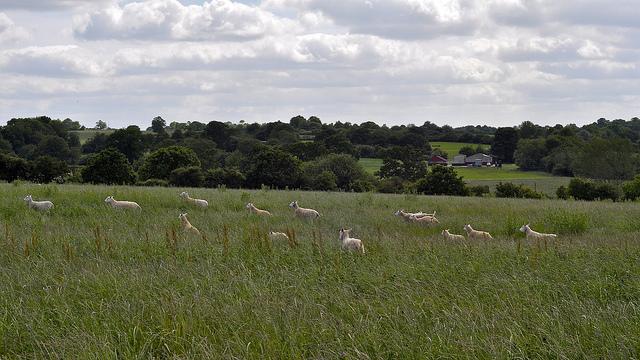Are all of the animals in the picture looking in the same direction?
Concise answer only. Yes. Are these sheep lost?
Quick response, please. No. How many animals can be seen?
Write a very short answer. 13. How many animals are in this scene?
Answer briefly. 13. What are the animals?
Give a very brief answer. Sheep. Does the grass need to be mowed?
Give a very brief answer. Yes. 